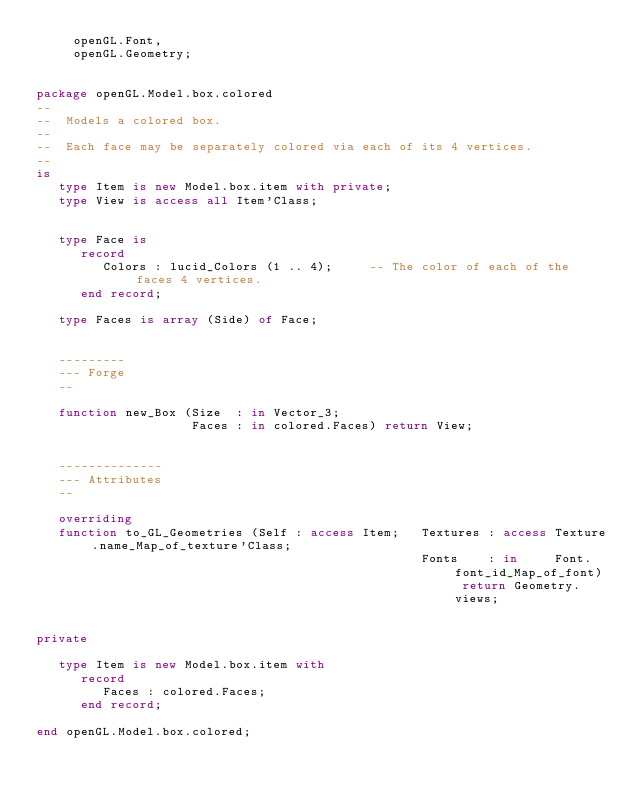Convert code to text. <code><loc_0><loc_0><loc_500><loc_500><_Ada_>     openGL.Font,
     openGL.Geometry;


package openGL.Model.box.colored
--
--  Models a colored box.
--
--  Each face may be separately colored via each of its 4 vertices.
--
is
   type Item is new Model.box.item with private;
   type View is access all Item'Class;


   type Face is
      record
         Colors : lucid_Colors (1 .. 4);     -- The color of each of the faces 4 vertices.
      end record;

   type Faces is array (Side) of Face;


   ---------
   --- Forge
   --

   function new_Box (Size  : in Vector_3;
                     Faces : in colored.Faces) return View;


   --------------
   --- Attributes
   --

   overriding
   function to_GL_Geometries (Self : access Item;   Textures : access Texture.name_Map_of_texture'Class;
                                                    Fonts    : in     Font.font_id_Map_of_font) return Geometry.views;


private

   type Item is new Model.box.item with
      record
         Faces : colored.Faces;
      end record;

end openGL.Model.box.colored;
</code> 